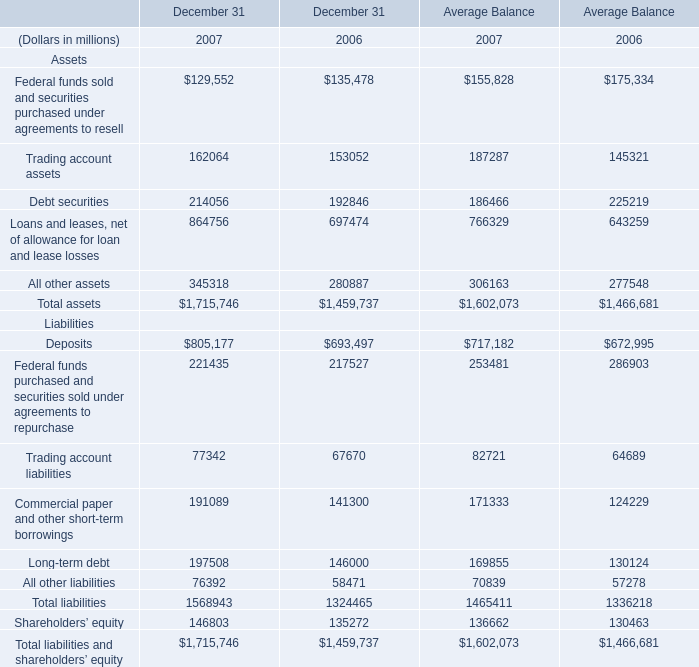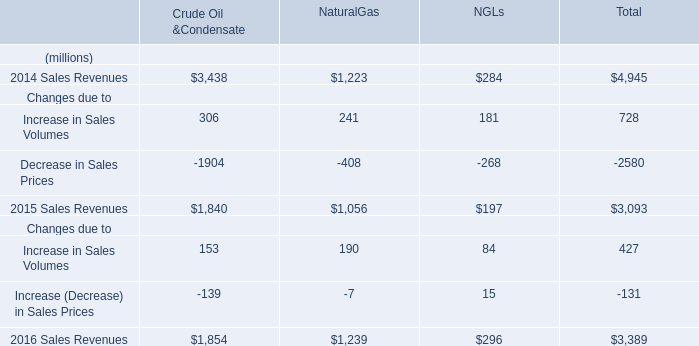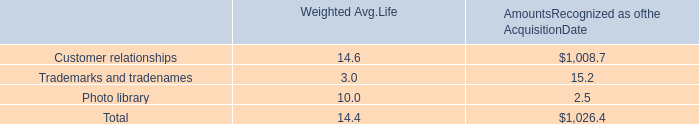what percent of the overall purchase value of star pizza was in customer relationship intangible assets and goodwill? 
Computations: ((2.2 + 24.8) / 34.6)
Answer: 0.78035. 